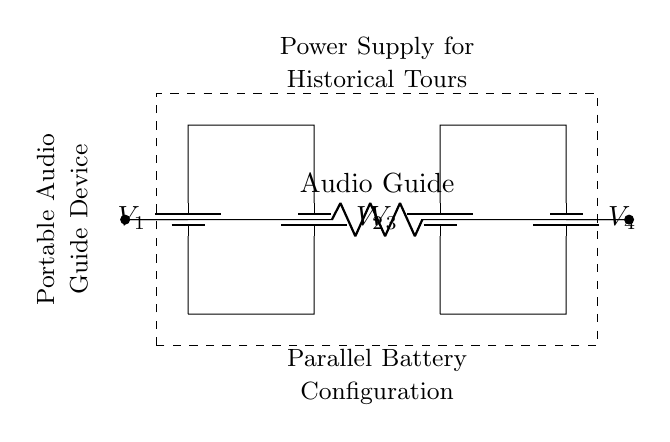What type of configuration is used in this circuit? The circuit shows a parallel configuration as indicated by the side-by-side arrangement of the batteries and the common connection to the load.
Answer: Parallel How many batteries are connected in this circuit? The circuit diagram illustrates four batteries depicted in two sets of parallel arrangements.
Answer: Four What is the role of the component labeled "Audio Guide"? The "Audio Guide" acts as the load in the circuit, drawing power from the batteries to operate the portable audio guide device.
Answer: Load What happens to the voltage if one battery fails in a parallel configuration? If one battery fails, the total voltage remains the same as the other batteries because in parallel configurations, the voltage across each branch is identical to the voltage across the power source.
Answer: Voltage remains the same What is the overall voltage provided by the battery configuration if they are all identical? Assuming the batteries are identical and each has a voltage of V, the overall voltage is V, since parallel configurations do not add voltages, only currents.
Answer: V Why would a parallel configuration be advantageous for a portable audio guide? A parallel configuration allows for extended operation time since the capacity is increased, providing longer use without replacing batteries, and ensuring continuous power.
Answer: Extended operation 